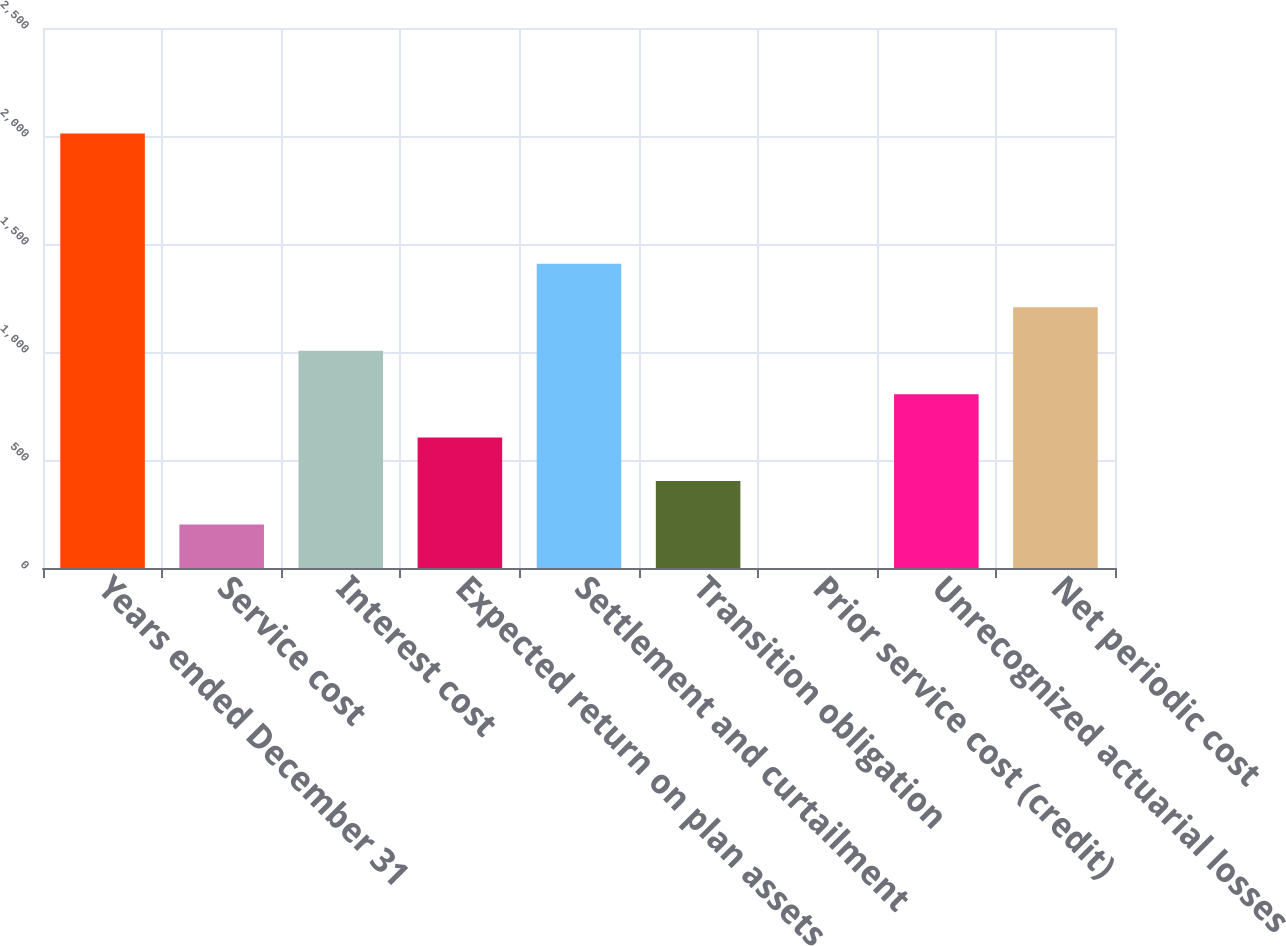Convert chart to OTSL. <chart><loc_0><loc_0><loc_500><loc_500><bar_chart><fcel>Years ended December 31<fcel>Service cost<fcel>Interest cost<fcel>Expected return on plan assets<fcel>Settlement and curtailment<fcel>Transition obligation<fcel>Prior service cost (credit)<fcel>Unrecognized actuarial losses<fcel>Net periodic cost<nl><fcel>2012<fcel>201.29<fcel>1006.05<fcel>603.67<fcel>1408.43<fcel>402.48<fcel>0.1<fcel>804.86<fcel>1207.24<nl></chart> 